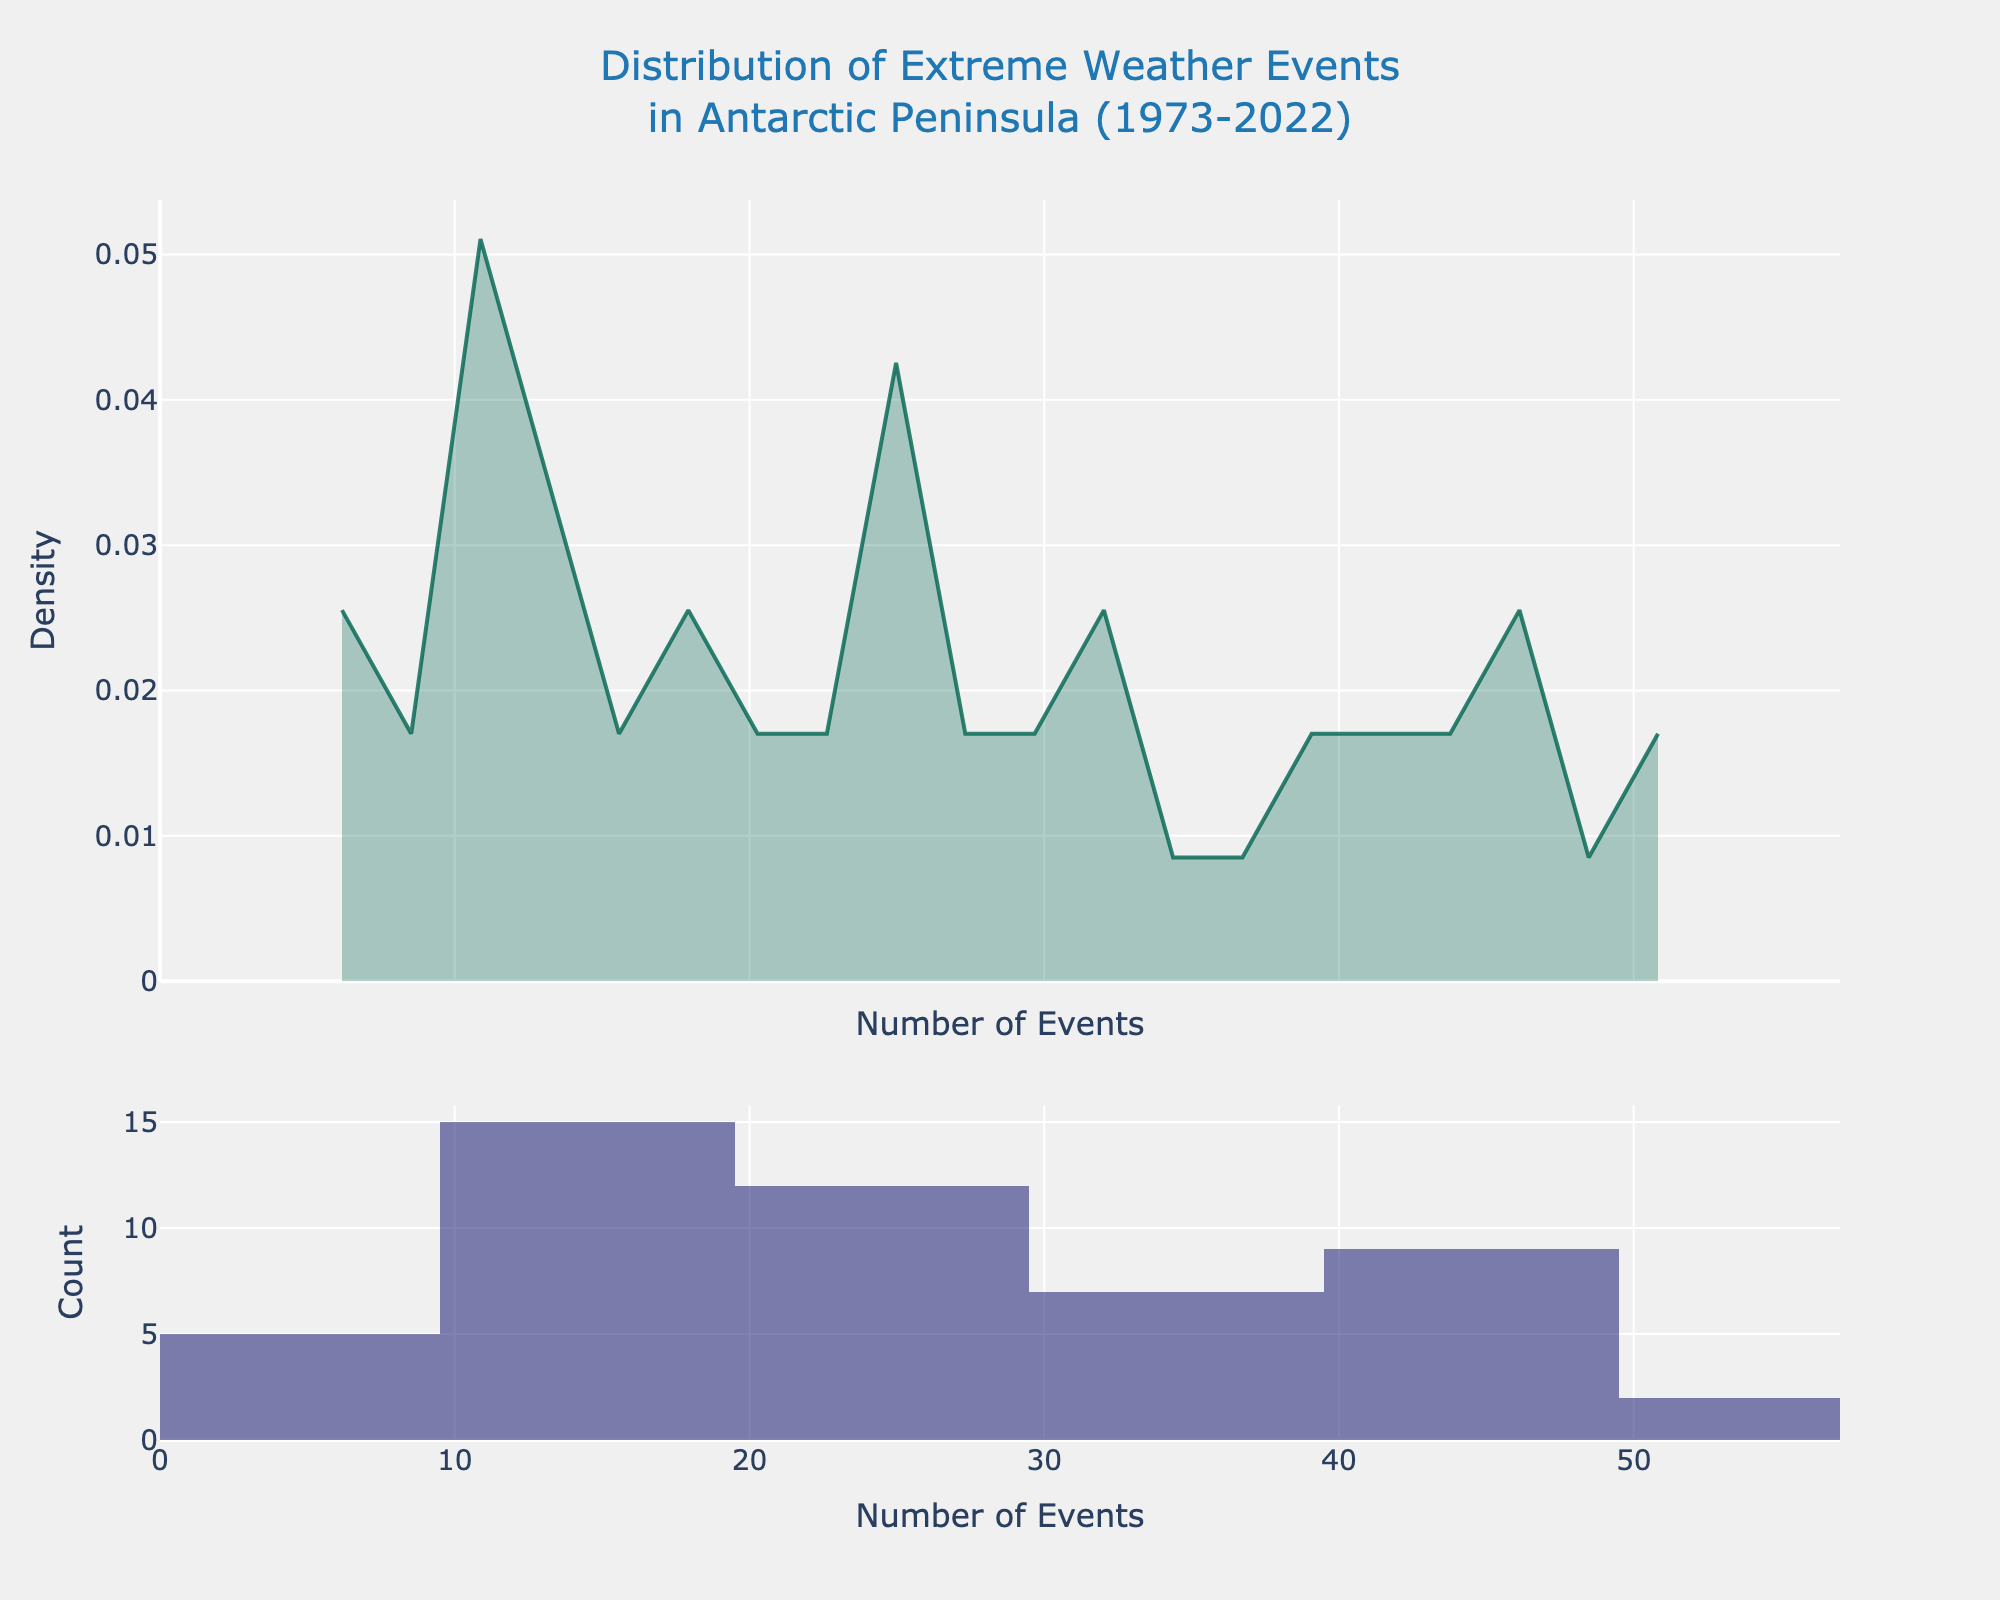What is the title of the figure? The title is placed at the top of the figure. It reads "Distribution of Extreme Weather Events in Antarctic Peninsula (1973-2022)"
Answer: Distribution of Extreme Weather Events in Antarctic Peninsula (1973-2022) What does the x-axis represent? The x-axis label is "Number of Events," indicating it represents the count of extreme weather events.
Answer: Number of Events What are the ranges shown on the x-axis? The x-axis range is provided visually. It starts from 0 and goes up to approximately 55.
Answer: 0 to 55 How many density peaks are visible in the KDE plot? By observing the KDE plot, we can see there is one clear peak.
Answer: One What is the general trend shown in the histogram for the frequency of extreme weather events? The histogram bars gradually increase in height from left to right, indicating a rising trend in event frequency over the years.
Answer: Increasing trend What is the count of the most frequently occurring bin in the histogram? The tallest bar in the histogram gives the highest count, which visually looks closest to around 8-10.
Answer: 8-10 Is there a noticeable difference between the early and later years in terms of event frequency distribution? The histogram shows fewer events in the early years (left side) and more events in the later years (right side). The KDE curve also rises more on the right, suggesting increased event frequency over time.
Answer: Yes, increased events over time What is the approximate density value at the peak of the KDE? By observing the peak of the KDE plot, the approximate density value appears to be around 0.03 to 0.04.
Answer: 0.03 to 0.04 What's the central tendency of extreme weather events as shown in the histogram? The central bars of the histogram and the central peak of the KDE suggest that the mode is around the mid-30s to 40s range.
Answer: 35 to 40 Which section of the KDE plot indicates the highest density of extreme weather events? The highest peak of the KDE plot is at around the mid-30s to 40s range, indicating the highest density of extreme weather events.
Answer: Mid-30s to 40s 